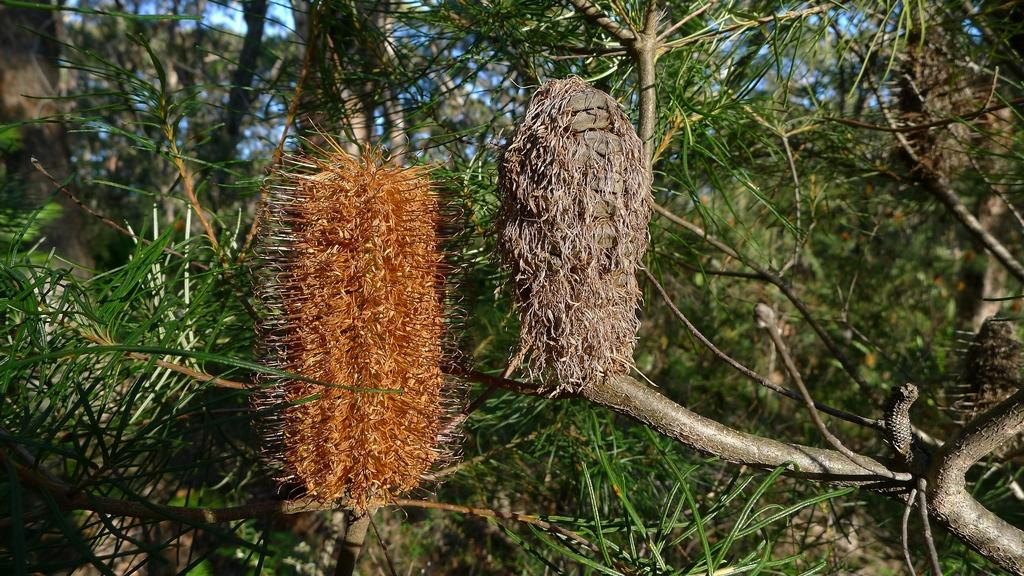What is located on the stem of a plant in the image? There is a group of leaves on the stem of a plant in the image. What can be seen in the background of the image? There is a group of trees and the sky visible in the background of the image. How many pages of a book can be seen in the image? There are no pages of a book present in the image. Is there a cobweb visible in the image? There is no cobweb present in the image. Can you see a goat in the image? There is no goat present in the image. 